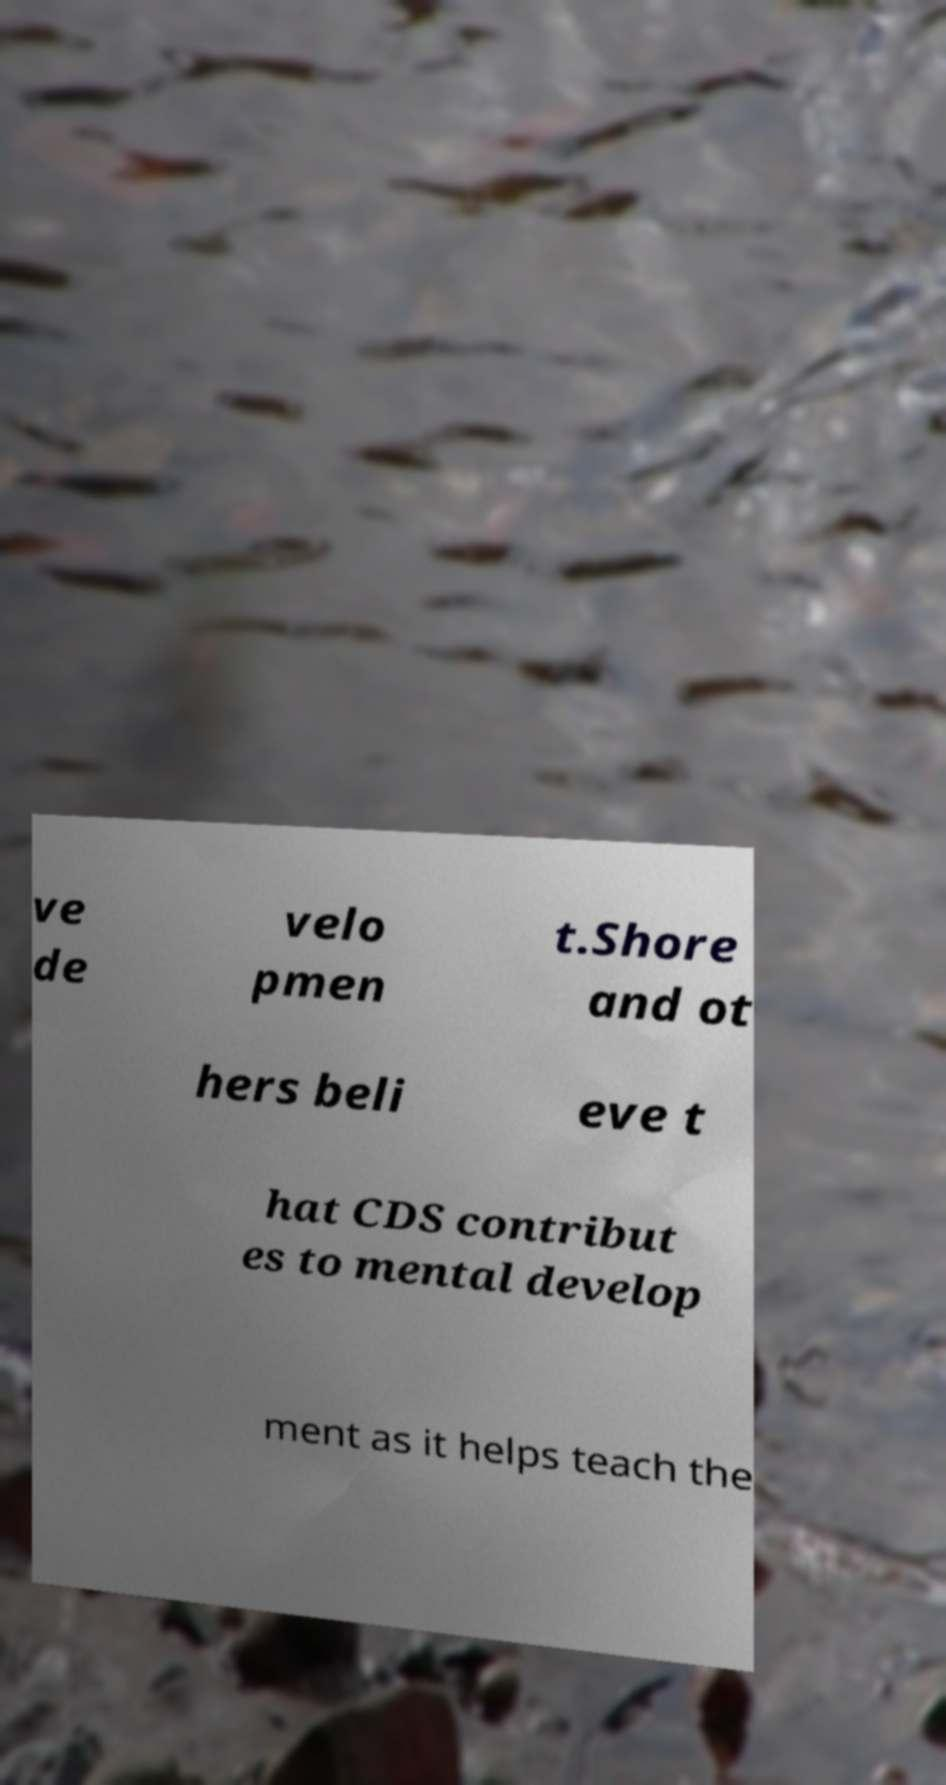Could you extract and type out the text from this image? ve de velo pmen t.Shore and ot hers beli eve t hat CDS contribut es to mental develop ment as it helps teach the 